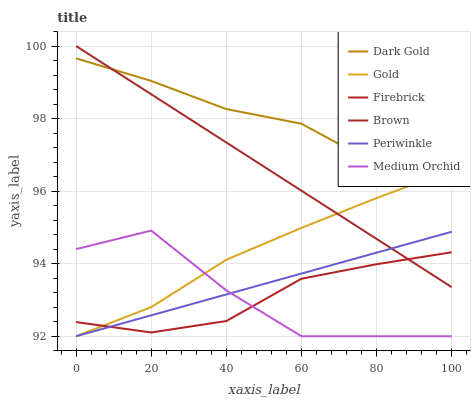Does Gold have the minimum area under the curve?
Answer yes or no. No. Does Gold have the maximum area under the curve?
Answer yes or no. No. Is Gold the smoothest?
Answer yes or no. No. Is Gold the roughest?
Answer yes or no. No. Does Dark Gold have the lowest value?
Answer yes or no. No. Does Gold have the highest value?
Answer yes or no. No. Is Firebrick less than Dark Gold?
Answer yes or no. Yes. Is Dark Gold greater than Medium Orchid?
Answer yes or no. Yes. Does Firebrick intersect Dark Gold?
Answer yes or no. No. 